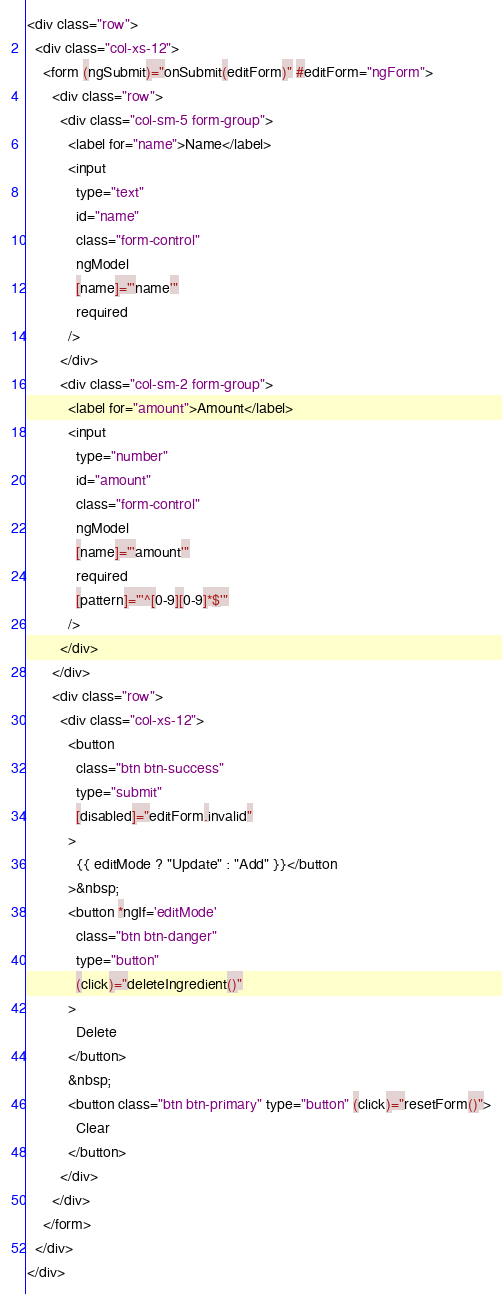Convert code to text. <code><loc_0><loc_0><loc_500><loc_500><_HTML_><div class="row">
  <div class="col-xs-12">
    <form (ngSubmit)="onSubmit(editForm)" #editForm="ngForm">
      <div class="row">
        <div class="col-sm-5 form-group">
          <label for="name">Name</label>
          <input
            type="text"
            id="name"
            class="form-control"
            ngModel
            [name]="'name'"
            required
          />
        </div>
        <div class="col-sm-2 form-group">
          <label for="amount">Amount</label>
          <input
            type="number"
            id="amount"
            class="form-control"
            ngModel
            [name]="'amount'"
            required
            [pattern]="'^[0-9][0-9]*$'"
          />
        </div>
      </div>
      <div class="row">
        <div class="col-xs-12">
          <button
            class="btn btn-success"
            type="submit"
            [disabled]="editForm.invalid"
          >
            {{ editMode ? "Update" : "Add" }}</button
          >&nbsp;
          <button *ngIf='editMode'
            class="btn btn-danger"
            type="button"
            (click)="deleteIngredient()"
          >
            Delete
          </button>
          &nbsp;
          <button class="btn btn-primary" type="button" (click)="resetForm()">
            Clear
          </button>
        </div>
      </div>
    </form>
  </div>
</div>
</code> 